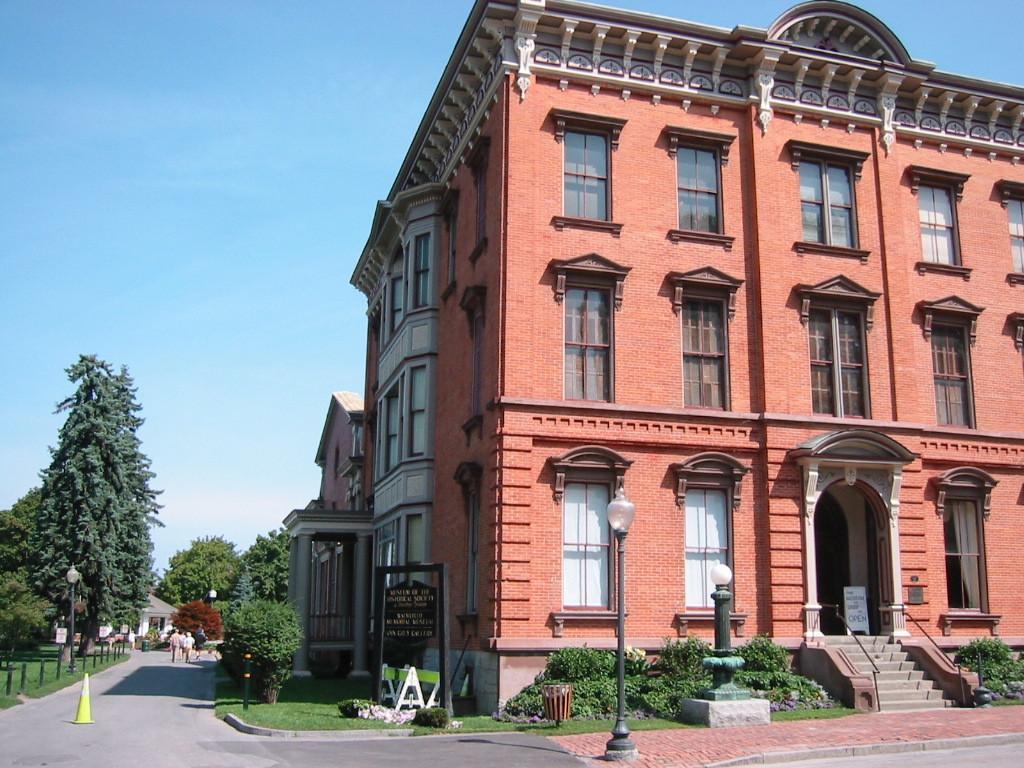In one or two sentences, can you explain what this image depicts? In the image we can see a building and the windows of the building. There is a road, grass, trees, light pole, board, road cone, stars, plant and a pale blue sky. We can see there are even people wearing clothes. 